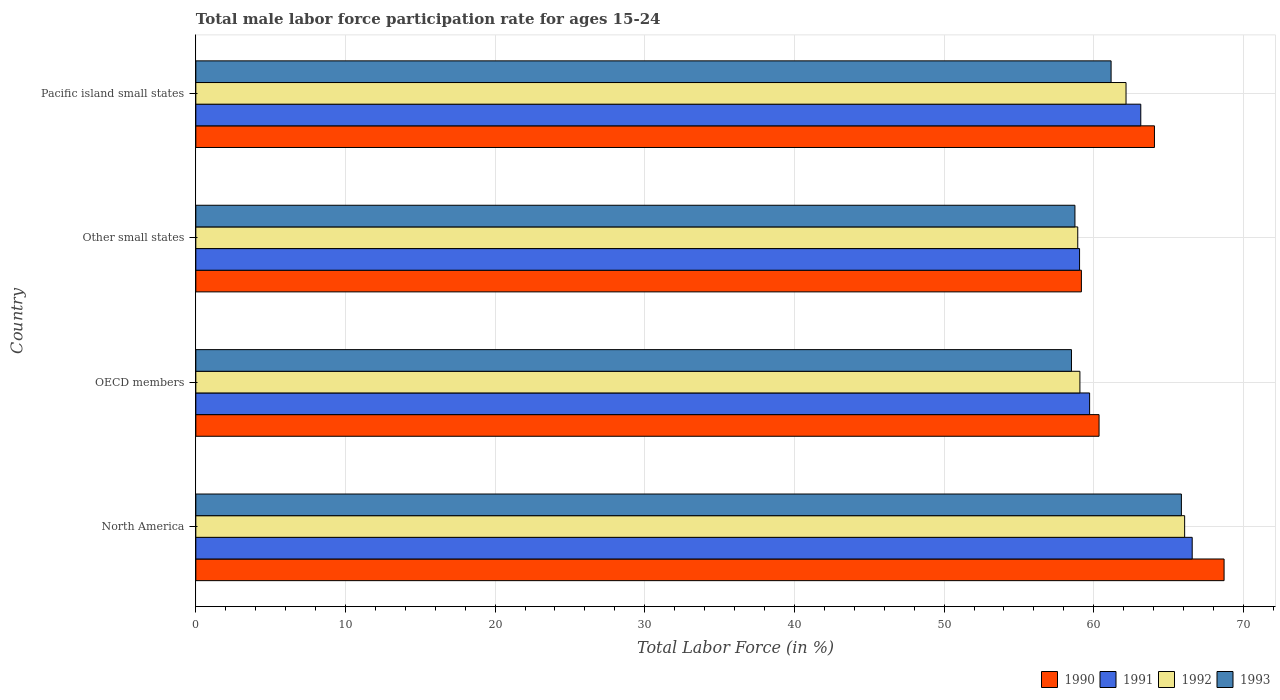How many different coloured bars are there?
Your response must be concise. 4. How many groups of bars are there?
Keep it short and to the point. 4. Are the number of bars per tick equal to the number of legend labels?
Ensure brevity in your answer.  Yes. What is the label of the 2nd group of bars from the top?
Offer a very short reply. Other small states. In how many cases, is the number of bars for a given country not equal to the number of legend labels?
Provide a short and direct response. 0. What is the male labor force participation rate in 1991 in OECD members?
Offer a very short reply. 59.73. Across all countries, what is the maximum male labor force participation rate in 1990?
Your response must be concise. 68.71. Across all countries, what is the minimum male labor force participation rate in 1992?
Ensure brevity in your answer.  58.93. In which country was the male labor force participation rate in 1991 minimum?
Your answer should be compact. Other small states. What is the total male labor force participation rate in 1992 in the graph?
Offer a very short reply. 246.25. What is the difference between the male labor force participation rate in 1993 in North America and that in Pacific island small states?
Your answer should be very brief. 4.7. What is the difference between the male labor force participation rate in 1993 in Other small states and the male labor force participation rate in 1991 in North America?
Offer a very short reply. -7.84. What is the average male labor force participation rate in 1991 per country?
Offer a very short reply. 62.13. What is the difference between the male labor force participation rate in 1990 and male labor force participation rate in 1993 in OECD members?
Offer a terse response. 1.84. What is the ratio of the male labor force participation rate in 1991 in North America to that in Other small states?
Your answer should be compact. 1.13. Is the difference between the male labor force participation rate in 1990 in OECD members and Pacific island small states greater than the difference between the male labor force participation rate in 1993 in OECD members and Pacific island small states?
Provide a short and direct response. No. What is the difference between the highest and the second highest male labor force participation rate in 1991?
Make the answer very short. 3.44. What is the difference between the highest and the lowest male labor force participation rate in 1993?
Keep it short and to the point. 7.34. Is the sum of the male labor force participation rate in 1990 in OECD members and Other small states greater than the maximum male labor force participation rate in 1993 across all countries?
Keep it short and to the point. Yes. Is it the case that in every country, the sum of the male labor force participation rate in 1992 and male labor force participation rate in 1991 is greater than the sum of male labor force participation rate in 1993 and male labor force participation rate in 1990?
Give a very brief answer. No. What does the 2nd bar from the bottom in North America represents?
Provide a succinct answer. 1991. How many bars are there?
Provide a succinct answer. 16. Are all the bars in the graph horizontal?
Provide a succinct answer. Yes. Where does the legend appear in the graph?
Make the answer very short. Bottom right. What is the title of the graph?
Your response must be concise. Total male labor force participation rate for ages 15-24. What is the label or title of the X-axis?
Give a very brief answer. Total Labor Force (in %). What is the Total Labor Force (in %) of 1990 in North America?
Provide a short and direct response. 68.71. What is the Total Labor Force (in %) of 1991 in North America?
Offer a terse response. 66.58. What is the Total Labor Force (in %) of 1992 in North America?
Your answer should be compact. 66.08. What is the Total Labor Force (in %) in 1993 in North America?
Give a very brief answer. 65.86. What is the Total Labor Force (in %) in 1990 in OECD members?
Offer a very short reply. 60.36. What is the Total Labor Force (in %) of 1991 in OECD members?
Ensure brevity in your answer.  59.73. What is the Total Labor Force (in %) in 1992 in OECD members?
Ensure brevity in your answer.  59.08. What is the Total Labor Force (in %) in 1993 in OECD members?
Provide a short and direct response. 58.51. What is the Total Labor Force (in %) in 1990 in Other small states?
Your answer should be compact. 59.18. What is the Total Labor Force (in %) of 1991 in Other small states?
Ensure brevity in your answer.  59.05. What is the Total Labor Force (in %) of 1992 in Other small states?
Your response must be concise. 58.93. What is the Total Labor Force (in %) in 1993 in Other small states?
Your answer should be compact. 58.75. What is the Total Labor Force (in %) in 1990 in Pacific island small states?
Keep it short and to the point. 64.06. What is the Total Labor Force (in %) of 1991 in Pacific island small states?
Give a very brief answer. 63.15. What is the Total Labor Force (in %) of 1992 in Pacific island small states?
Offer a very short reply. 62.16. What is the Total Labor Force (in %) of 1993 in Pacific island small states?
Your answer should be compact. 61.16. Across all countries, what is the maximum Total Labor Force (in %) of 1990?
Offer a very short reply. 68.71. Across all countries, what is the maximum Total Labor Force (in %) of 1991?
Your answer should be very brief. 66.58. Across all countries, what is the maximum Total Labor Force (in %) in 1992?
Your answer should be very brief. 66.08. Across all countries, what is the maximum Total Labor Force (in %) in 1993?
Make the answer very short. 65.86. Across all countries, what is the minimum Total Labor Force (in %) of 1990?
Your answer should be very brief. 59.18. Across all countries, what is the minimum Total Labor Force (in %) in 1991?
Make the answer very short. 59.05. Across all countries, what is the minimum Total Labor Force (in %) of 1992?
Provide a short and direct response. 58.93. Across all countries, what is the minimum Total Labor Force (in %) of 1993?
Provide a short and direct response. 58.51. What is the total Total Labor Force (in %) of 1990 in the graph?
Ensure brevity in your answer.  252.3. What is the total Total Labor Force (in %) in 1991 in the graph?
Your answer should be compact. 248.51. What is the total Total Labor Force (in %) in 1992 in the graph?
Provide a succinct answer. 246.25. What is the total Total Labor Force (in %) in 1993 in the graph?
Provide a short and direct response. 244.28. What is the difference between the Total Labor Force (in %) in 1990 in North America and that in OECD members?
Offer a terse response. 8.35. What is the difference between the Total Labor Force (in %) in 1991 in North America and that in OECD members?
Your response must be concise. 6.86. What is the difference between the Total Labor Force (in %) in 1992 in North America and that in OECD members?
Make the answer very short. 7. What is the difference between the Total Labor Force (in %) in 1993 in North America and that in OECD members?
Your answer should be compact. 7.34. What is the difference between the Total Labor Force (in %) of 1990 in North America and that in Other small states?
Offer a terse response. 9.54. What is the difference between the Total Labor Force (in %) in 1991 in North America and that in Other small states?
Provide a succinct answer. 7.53. What is the difference between the Total Labor Force (in %) in 1992 in North America and that in Other small states?
Ensure brevity in your answer.  7.14. What is the difference between the Total Labor Force (in %) in 1993 in North America and that in Other small states?
Provide a succinct answer. 7.11. What is the difference between the Total Labor Force (in %) in 1990 in North America and that in Pacific island small states?
Provide a succinct answer. 4.65. What is the difference between the Total Labor Force (in %) in 1991 in North America and that in Pacific island small states?
Give a very brief answer. 3.44. What is the difference between the Total Labor Force (in %) of 1992 in North America and that in Pacific island small states?
Provide a short and direct response. 3.92. What is the difference between the Total Labor Force (in %) in 1993 in North America and that in Pacific island small states?
Make the answer very short. 4.7. What is the difference between the Total Labor Force (in %) in 1990 in OECD members and that in Other small states?
Provide a succinct answer. 1.18. What is the difference between the Total Labor Force (in %) in 1991 in OECD members and that in Other small states?
Offer a very short reply. 0.67. What is the difference between the Total Labor Force (in %) of 1992 in OECD members and that in Other small states?
Offer a very short reply. 0.14. What is the difference between the Total Labor Force (in %) in 1993 in OECD members and that in Other small states?
Provide a short and direct response. -0.23. What is the difference between the Total Labor Force (in %) in 1990 in OECD members and that in Pacific island small states?
Offer a terse response. -3.7. What is the difference between the Total Labor Force (in %) of 1991 in OECD members and that in Pacific island small states?
Offer a very short reply. -3.42. What is the difference between the Total Labor Force (in %) in 1992 in OECD members and that in Pacific island small states?
Make the answer very short. -3.08. What is the difference between the Total Labor Force (in %) in 1993 in OECD members and that in Pacific island small states?
Make the answer very short. -2.65. What is the difference between the Total Labor Force (in %) of 1990 in Other small states and that in Pacific island small states?
Offer a very short reply. -4.88. What is the difference between the Total Labor Force (in %) in 1991 in Other small states and that in Pacific island small states?
Your response must be concise. -4.09. What is the difference between the Total Labor Force (in %) in 1992 in Other small states and that in Pacific island small states?
Offer a very short reply. -3.23. What is the difference between the Total Labor Force (in %) of 1993 in Other small states and that in Pacific island small states?
Ensure brevity in your answer.  -2.42. What is the difference between the Total Labor Force (in %) of 1990 in North America and the Total Labor Force (in %) of 1991 in OECD members?
Offer a terse response. 8.99. What is the difference between the Total Labor Force (in %) in 1990 in North America and the Total Labor Force (in %) in 1992 in OECD members?
Your answer should be very brief. 9.63. What is the difference between the Total Labor Force (in %) of 1990 in North America and the Total Labor Force (in %) of 1993 in OECD members?
Your answer should be compact. 10.2. What is the difference between the Total Labor Force (in %) of 1991 in North America and the Total Labor Force (in %) of 1992 in OECD members?
Ensure brevity in your answer.  7.5. What is the difference between the Total Labor Force (in %) of 1991 in North America and the Total Labor Force (in %) of 1993 in OECD members?
Offer a terse response. 8.07. What is the difference between the Total Labor Force (in %) of 1992 in North America and the Total Labor Force (in %) of 1993 in OECD members?
Provide a succinct answer. 7.56. What is the difference between the Total Labor Force (in %) of 1990 in North America and the Total Labor Force (in %) of 1991 in Other small states?
Provide a succinct answer. 9.66. What is the difference between the Total Labor Force (in %) of 1990 in North America and the Total Labor Force (in %) of 1992 in Other small states?
Offer a terse response. 9.78. What is the difference between the Total Labor Force (in %) in 1990 in North America and the Total Labor Force (in %) in 1993 in Other small states?
Your answer should be compact. 9.97. What is the difference between the Total Labor Force (in %) in 1991 in North America and the Total Labor Force (in %) in 1992 in Other small states?
Ensure brevity in your answer.  7.65. What is the difference between the Total Labor Force (in %) in 1991 in North America and the Total Labor Force (in %) in 1993 in Other small states?
Give a very brief answer. 7.84. What is the difference between the Total Labor Force (in %) in 1992 in North America and the Total Labor Force (in %) in 1993 in Other small states?
Your response must be concise. 7.33. What is the difference between the Total Labor Force (in %) in 1990 in North America and the Total Labor Force (in %) in 1991 in Pacific island small states?
Offer a terse response. 5.57. What is the difference between the Total Labor Force (in %) in 1990 in North America and the Total Labor Force (in %) in 1992 in Pacific island small states?
Your answer should be very brief. 6.55. What is the difference between the Total Labor Force (in %) of 1990 in North America and the Total Labor Force (in %) of 1993 in Pacific island small states?
Provide a short and direct response. 7.55. What is the difference between the Total Labor Force (in %) of 1991 in North America and the Total Labor Force (in %) of 1992 in Pacific island small states?
Your answer should be compact. 4.42. What is the difference between the Total Labor Force (in %) of 1991 in North America and the Total Labor Force (in %) of 1993 in Pacific island small states?
Keep it short and to the point. 5.42. What is the difference between the Total Labor Force (in %) in 1992 in North America and the Total Labor Force (in %) in 1993 in Pacific island small states?
Give a very brief answer. 4.91. What is the difference between the Total Labor Force (in %) in 1990 in OECD members and the Total Labor Force (in %) in 1991 in Other small states?
Ensure brevity in your answer.  1.3. What is the difference between the Total Labor Force (in %) in 1990 in OECD members and the Total Labor Force (in %) in 1992 in Other small states?
Keep it short and to the point. 1.42. What is the difference between the Total Labor Force (in %) in 1990 in OECD members and the Total Labor Force (in %) in 1993 in Other small states?
Offer a terse response. 1.61. What is the difference between the Total Labor Force (in %) of 1991 in OECD members and the Total Labor Force (in %) of 1992 in Other small states?
Ensure brevity in your answer.  0.79. What is the difference between the Total Labor Force (in %) in 1991 in OECD members and the Total Labor Force (in %) in 1993 in Other small states?
Ensure brevity in your answer.  0.98. What is the difference between the Total Labor Force (in %) of 1992 in OECD members and the Total Labor Force (in %) of 1993 in Other small states?
Make the answer very short. 0.33. What is the difference between the Total Labor Force (in %) in 1990 in OECD members and the Total Labor Force (in %) in 1991 in Pacific island small states?
Make the answer very short. -2.79. What is the difference between the Total Labor Force (in %) of 1990 in OECD members and the Total Labor Force (in %) of 1992 in Pacific island small states?
Ensure brevity in your answer.  -1.8. What is the difference between the Total Labor Force (in %) of 1990 in OECD members and the Total Labor Force (in %) of 1993 in Pacific island small states?
Your response must be concise. -0.8. What is the difference between the Total Labor Force (in %) of 1991 in OECD members and the Total Labor Force (in %) of 1992 in Pacific island small states?
Keep it short and to the point. -2.43. What is the difference between the Total Labor Force (in %) of 1991 in OECD members and the Total Labor Force (in %) of 1993 in Pacific island small states?
Offer a very short reply. -1.44. What is the difference between the Total Labor Force (in %) in 1992 in OECD members and the Total Labor Force (in %) in 1993 in Pacific island small states?
Your answer should be compact. -2.08. What is the difference between the Total Labor Force (in %) of 1990 in Other small states and the Total Labor Force (in %) of 1991 in Pacific island small states?
Offer a very short reply. -3.97. What is the difference between the Total Labor Force (in %) in 1990 in Other small states and the Total Labor Force (in %) in 1992 in Pacific island small states?
Offer a very short reply. -2.98. What is the difference between the Total Labor Force (in %) in 1990 in Other small states and the Total Labor Force (in %) in 1993 in Pacific island small states?
Provide a short and direct response. -1.98. What is the difference between the Total Labor Force (in %) in 1991 in Other small states and the Total Labor Force (in %) in 1992 in Pacific island small states?
Give a very brief answer. -3.1. What is the difference between the Total Labor Force (in %) of 1991 in Other small states and the Total Labor Force (in %) of 1993 in Pacific island small states?
Keep it short and to the point. -2.11. What is the difference between the Total Labor Force (in %) of 1992 in Other small states and the Total Labor Force (in %) of 1993 in Pacific island small states?
Give a very brief answer. -2.23. What is the average Total Labor Force (in %) in 1990 per country?
Offer a terse response. 63.08. What is the average Total Labor Force (in %) in 1991 per country?
Provide a short and direct response. 62.13. What is the average Total Labor Force (in %) of 1992 per country?
Your answer should be compact. 61.56. What is the average Total Labor Force (in %) of 1993 per country?
Ensure brevity in your answer.  61.07. What is the difference between the Total Labor Force (in %) in 1990 and Total Labor Force (in %) in 1991 in North America?
Your answer should be compact. 2.13. What is the difference between the Total Labor Force (in %) in 1990 and Total Labor Force (in %) in 1992 in North America?
Your answer should be compact. 2.64. What is the difference between the Total Labor Force (in %) of 1990 and Total Labor Force (in %) of 1993 in North America?
Offer a terse response. 2.85. What is the difference between the Total Labor Force (in %) of 1991 and Total Labor Force (in %) of 1992 in North America?
Keep it short and to the point. 0.51. What is the difference between the Total Labor Force (in %) of 1991 and Total Labor Force (in %) of 1993 in North America?
Your response must be concise. 0.72. What is the difference between the Total Labor Force (in %) of 1992 and Total Labor Force (in %) of 1993 in North America?
Keep it short and to the point. 0.22. What is the difference between the Total Labor Force (in %) in 1990 and Total Labor Force (in %) in 1991 in OECD members?
Your answer should be compact. 0.63. What is the difference between the Total Labor Force (in %) of 1990 and Total Labor Force (in %) of 1992 in OECD members?
Offer a very short reply. 1.28. What is the difference between the Total Labor Force (in %) in 1990 and Total Labor Force (in %) in 1993 in OECD members?
Your answer should be very brief. 1.84. What is the difference between the Total Labor Force (in %) of 1991 and Total Labor Force (in %) of 1992 in OECD members?
Offer a terse response. 0.65. What is the difference between the Total Labor Force (in %) in 1991 and Total Labor Force (in %) in 1993 in OECD members?
Your answer should be very brief. 1.21. What is the difference between the Total Labor Force (in %) of 1992 and Total Labor Force (in %) of 1993 in OECD members?
Ensure brevity in your answer.  0.56. What is the difference between the Total Labor Force (in %) of 1990 and Total Labor Force (in %) of 1991 in Other small states?
Ensure brevity in your answer.  0.12. What is the difference between the Total Labor Force (in %) in 1990 and Total Labor Force (in %) in 1992 in Other small states?
Your response must be concise. 0.24. What is the difference between the Total Labor Force (in %) of 1990 and Total Labor Force (in %) of 1993 in Other small states?
Provide a short and direct response. 0.43. What is the difference between the Total Labor Force (in %) in 1991 and Total Labor Force (in %) in 1992 in Other small states?
Your answer should be compact. 0.12. What is the difference between the Total Labor Force (in %) in 1991 and Total Labor Force (in %) in 1993 in Other small states?
Your response must be concise. 0.31. What is the difference between the Total Labor Force (in %) in 1992 and Total Labor Force (in %) in 1993 in Other small states?
Your response must be concise. 0.19. What is the difference between the Total Labor Force (in %) of 1990 and Total Labor Force (in %) of 1991 in Pacific island small states?
Provide a succinct answer. 0.91. What is the difference between the Total Labor Force (in %) of 1990 and Total Labor Force (in %) of 1992 in Pacific island small states?
Your answer should be compact. 1.9. What is the difference between the Total Labor Force (in %) in 1990 and Total Labor Force (in %) in 1993 in Pacific island small states?
Provide a succinct answer. 2.9. What is the difference between the Total Labor Force (in %) in 1991 and Total Labor Force (in %) in 1992 in Pacific island small states?
Offer a very short reply. 0.99. What is the difference between the Total Labor Force (in %) of 1991 and Total Labor Force (in %) of 1993 in Pacific island small states?
Ensure brevity in your answer.  1.98. What is the ratio of the Total Labor Force (in %) in 1990 in North America to that in OECD members?
Offer a very short reply. 1.14. What is the ratio of the Total Labor Force (in %) in 1991 in North America to that in OECD members?
Offer a very short reply. 1.11. What is the ratio of the Total Labor Force (in %) of 1992 in North America to that in OECD members?
Ensure brevity in your answer.  1.12. What is the ratio of the Total Labor Force (in %) in 1993 in North America to that in OECD members?
Your answer should be compact. 1.13. What is the ratio of the Total Labor Force (in %) in 1990 in North America to that in Other small states?
Ensure brevity in your answer.  1.16. What is the ratio of the Total Labor Force (in %) in 1991 in North America to that in Other small states?
Give a very brief answer. 1.13. What is the ratio of the Total Labor Force (in %) of 1992 in North America to that in Other small states?
Ensure brevity in your answer.  1.12. What is the ratio of the Total Labor Force (in %) of 1993 in North America to that in Other small states?
Your answer should be very brief. 1.12. What is the ratio of the Total Labor Force (in %) in 1990 in North America to that in Pacific island small states?
Provide a short and direct response. 1.07. What is the ratio of the Total Labor Force (in %) in 1991 in North America to that in Pacific island small states?
Give a very brief answer. 1.05. What is the ratio of the Total Labor Force (in %) in 1992 in North America to that in Pacific island small states?
Your response must be concise. 1.06. What is the ratio of the Total Labor Force (in %) of 1993 in North America to that in Pacific island small states?
Provide a succinct answer. 1.08. What is the ratio of the Total Labor Force (in %) in 1991 in OECD members to that in Other small states?
Your response must be concise. 1.01. What is the ratio of the Total Labor Force (in %) in 1992 in OECD members to that in Other small states?
Your response must be concise. 1. What is the ratio of the Total Labor Force (in %) of 1993 in OECD members to that in Other small states?
Offer a very short reply. 1. What is the ratio of the Total Labor Force (in %) of 1990 in OECD members to that in Pacific island small states?
Provide a short and direct response. 0.94. What is the ratio of the Total Labor Force (in %) of 1991 in OECD members to that in Pacific island small states?
Give a very brief answer. 0.95. What is the ratio of the Total Labor Force (in %) of 1992 in OECD members to that in Pacific island small states?
Make the answer very short. 0.95. What is the ratio of the Total Labor Force (in %) of 1993 in OECD members to that in Pacific island small states?
Give a very brief answer. 0.96. What is the ratio of the Total Labor Force (in %) of 1990 in Other small states to that in Pacific island small states?
Offer a terse response. 0.92. What is the ratio of the Total Labor Force (in %) of 1991 in Other small states to that in Pacific island small states?
Make the answer very short. 0.94. What is the ratio of the Total Labor Force (in %) in 1992 in Other small states to that in Pacific island small states?
Keep it short and to the point. 0.95. What is the ratio of the Total Labor Force (in %) of 1993 in Other small states to that in Pacific island small states?
Keep it short and to the point. 0.96. What is the difference between the highest and the second highest Total Labor Force (in %) in 1990?
Offer a very short reply. 4.65. What is the difference between the highest and the second highest Total Labor Force (in %) of 1991?
Ensure brevity in your answer.  3.44. What is the difference between the highest and the second highest Total Labor Force (in %) of 1992?
Make the answer very short. 3.92. What is the difference between the highest and the second highest Total Labor Force (in %) in 1993?
Offer a very short reply. 4.7. What is the difference between the highest and the lowest Total Labor Force (in %) in 1990?
Your answer should be very brief. 9.54. What is the difference between the highest and the lowest Total Labor Force (in %) of 1991?
Provide a succinct answer. 7.53. What is the difference between the highest and the lowest Total Labor Force (in %) in 1992?
Your response must be concise. 7.14. What is the difference between the highest and the lowest Total Labor Force (in %) in 1993?
Your answer should be compact. 7.34. 